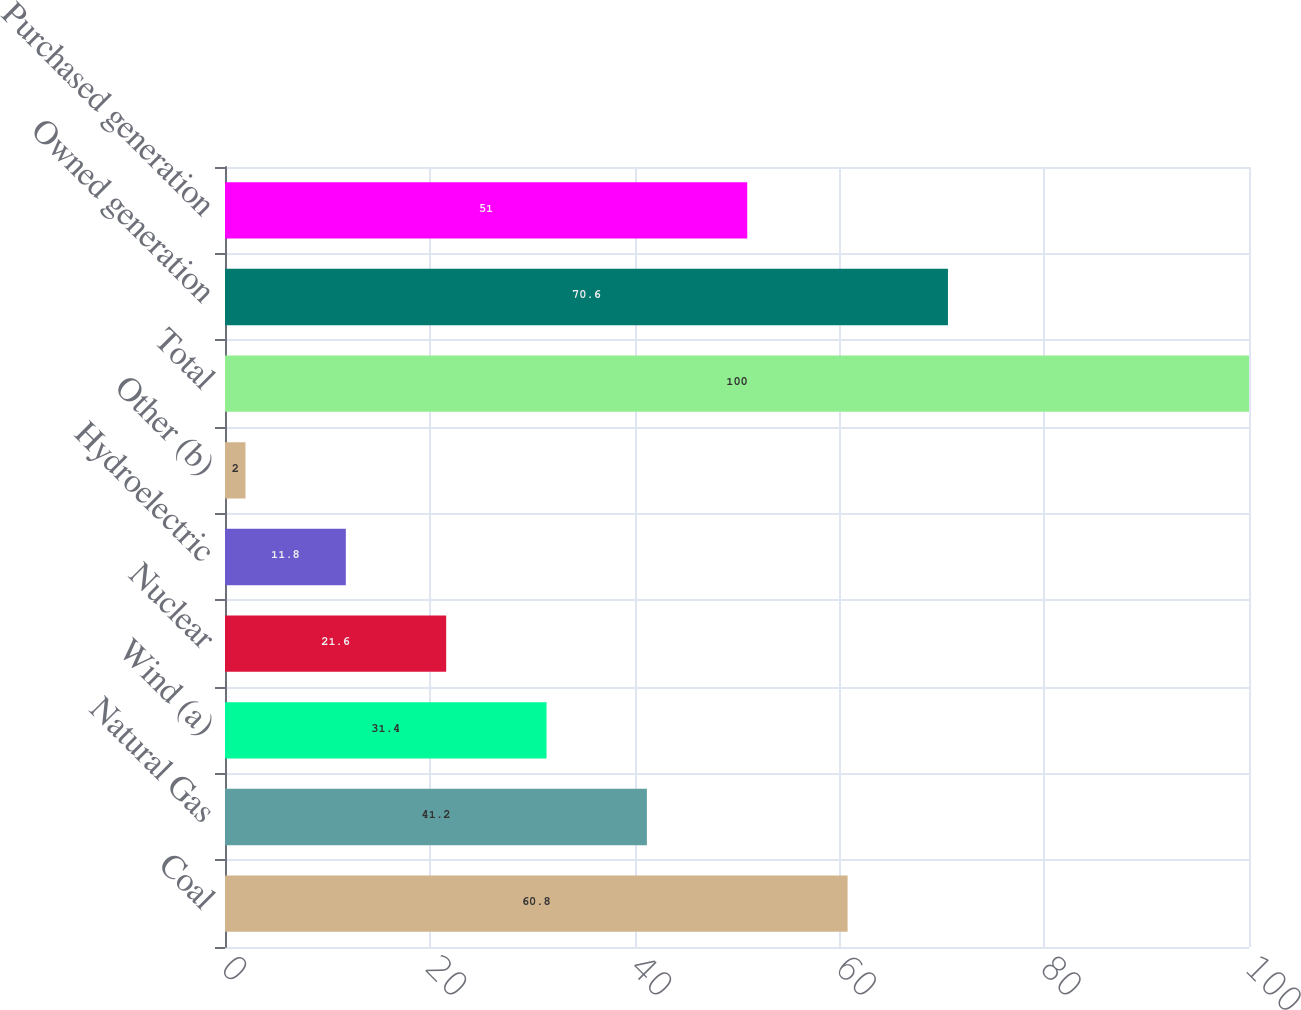Convert chart. <chart><loc_0><loc_0><loc_500><loc_500><bar_chart><fcel>Coal<fcel>Natural Gas<fcel>Wind (a)<fcel>Nuclear<fcel>Hydroelectric<fcel>Other (b)<fcel>Total<fcel>Owned generation<fcel>Purchased generation<nl><fcel>60.8<fcel>41.2<fcel>31.4<fcel>21.6<fcel>11.8<fcel>2<fcel>100<fcel>70.6<fcel>51<nl></chart> 